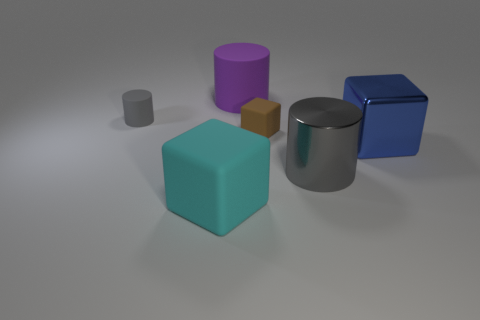Does the big shiny cylinder have the same color as the tiny cylinder?
Give a very brief answer. Yes. Are there more big cyan objects that are left of the purple cylinder than big shiny cylinders that are behind the brown block?
Give a very brief answer. Yes. There is a matte cylinder in front of the large purple rubber cylinder; is its color the same as the metallic cylinder?
Offer a terse response. Yes. Is there any other thing that has the same color as the large metal cylinder?
Give a very brief answer. Yes. Is the number of large rubber cylinders that are behind the gray shiny thing greater than the number of small red cylinders?
Your response must be concise. Yes. Does the cyan rubber cube have the same size as the brown matte object?
Offer a terse response. No. There is a large gray object that is the same shape as the large purple matte thing; what is its material?
Provide a short and direct response. Metal. Are there any other things that are made of the same material as the small cube?
Offer a very short reply. Yes. How many purple objects are either shiny cubes or large cylinders?
Keep it short and to the point. 1. What material is the gray cylinder that is on the left side of the cyan thing?
Offer a very short reply. Rubber. 